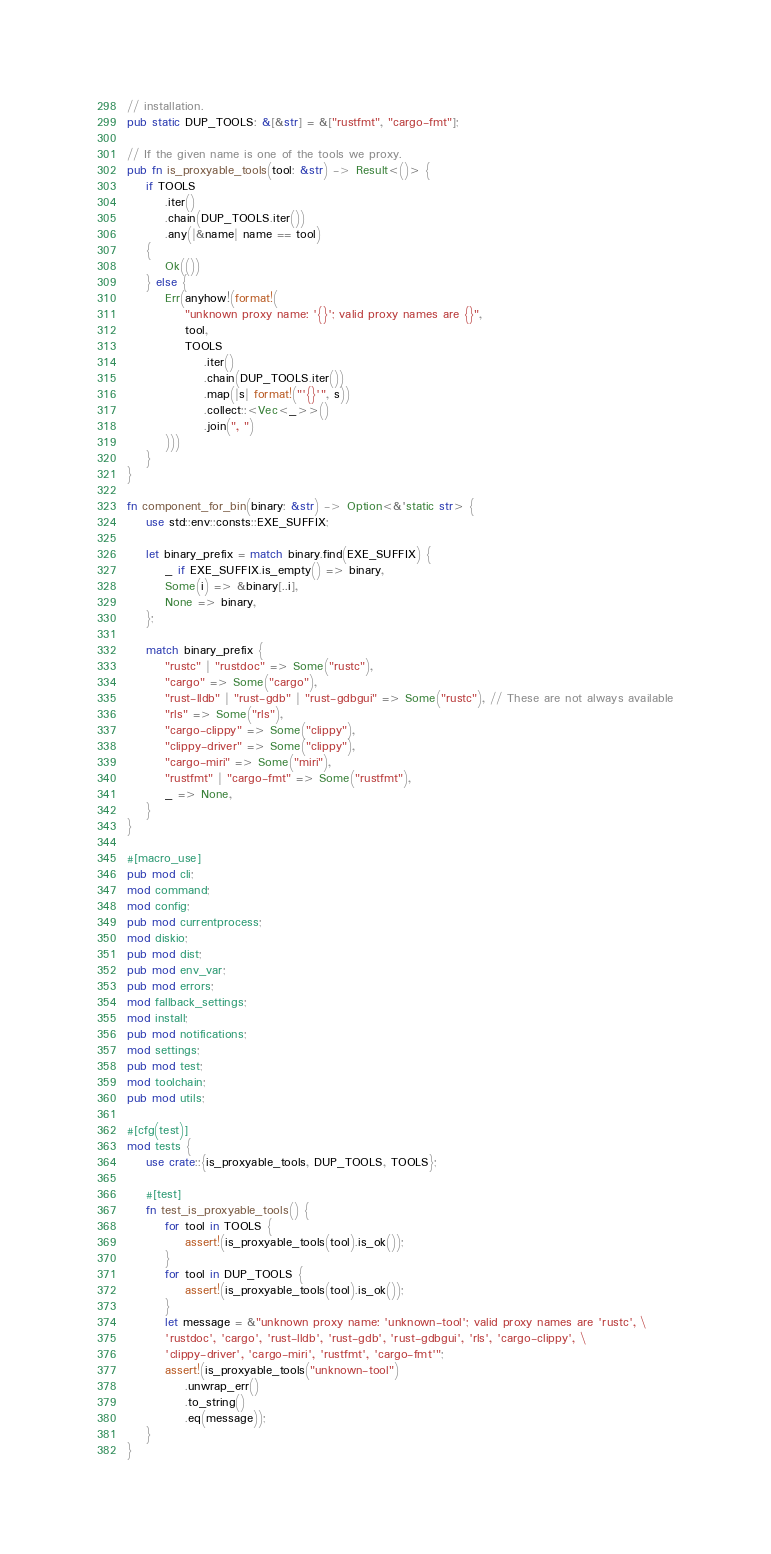<code> <loc_0><loc_0><loc_500><loc_500><_Rust_>// installation.
pub static DUP_TOOLS: &[&str] = &["rustfmt", "cargo-fmt"];

// If the given name is one of the tools we proxy.
pub fn is_proxyable_tools(tool: &str) -> Result<()> {
    if TOOLS
        .iter()
        .chain(DUP_TOOLS.iter())
        .any(|&name| name == tool)
    {
        Ok(())
    } else {
        Err(anyhow!(format!(
            "unknown proxy name: '{}'; valid proxy names are {}",
            tool,
            TOOLS
                .iter()
                .chain(DUP_TOOLS.iter())
                .map(|s| format!("'{}'", s))
                .collect::<Vec<_>>()
                .join(", ")
        )))
    }
}

fn component_for_bin(binary: &str) -> Option<&'static str> {
    use std::env::consts::EXE_SUFFIX;

    let binary_prefix = match binary.find(EXE_SUFFIX) {
        _ if EXE_SUFFIX.is_empty() => binary,
        Some(i) => &binary[..i],
        None => binary,
    };

    match binary_prefix {
        "rustc" | "rustdoc" => Some("rustc"),
        "cargo" => Some("cargo"),
        "rust-lldb" | "rust-gdb" | "rust-gdbgui" => Some("rustc"), // These are not always available
        "rls" => Some("rls"),
        "cargo-clippy" => Some("clippy"),
        "clippy-driver" => Some("clippy"),
        "cargo-miri" => Some("miri"),
        "rustfmt" | "cargo-fmt" => Some("rustfmt"),
        _ => None,
    }
}

#[macro_use]
pub mod cli;
mod command;
mod config;
pub mod currentprocess;
mod diskio;
pub mod dist;
pub mod env_var;
pub mod errors;
mod fallback_settings;
mod install;
pub mod notifications;
mod settings;
pub mod test;
mod toolchain;
pub mod utils;

#[cfg(test)]
mod tests {
    use crate::{is_proxyable_tools, DUP_TOOLS, TOOLS};

    #[test]
    fn test_is_proxyable_tools() {
        for tool in TOOLS {
            assert!(is_proxyable_tools(tool).is_ok());
        }
        for tool in DUP_TOOLS {
            assert!(is_proxyable_tools(tool).is_ok());
        }
        let message = &"unknown proxy name: 'unknown-tool'; valid proxy names are 'rustc', \
        'rustdoc', 'cargo', 'rust-lldb', 'rust-gdb', 'rust-gdbgui', 'rls', 'cargo-clippy', \
        'clippy-driver', 'cargo-miri', 'rustfmt', 'cargo-fmt'";
        assert!(is_proxyable_tools("unknown-tool")
            .unwrap_err()
            .to_string()
            .eq(message));
    }
}
</code> 